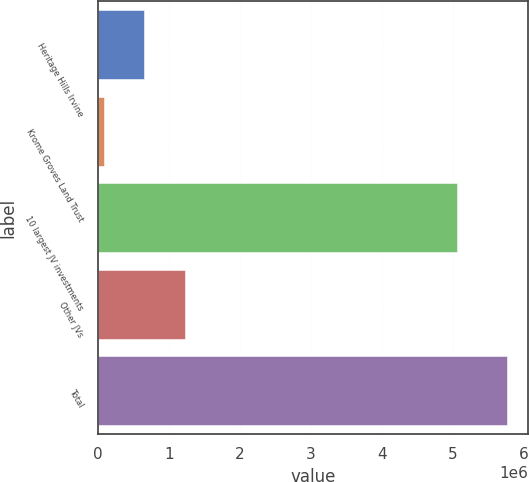Convert chart. <chart><loc_0><loc_0><loc_500><loc_500><bar_chart><fcel>Heritage Hills Irvine<fcel>Krome Groves Land Trust<fcel>10 largest JV investments<fcel>Other JVs<fcel>Total<nl><fcel>657503<fcel>89860<fcel>5.06071e+06<fcel>1.22515e+06<fcel>5.76629e+06<nl></chart> 